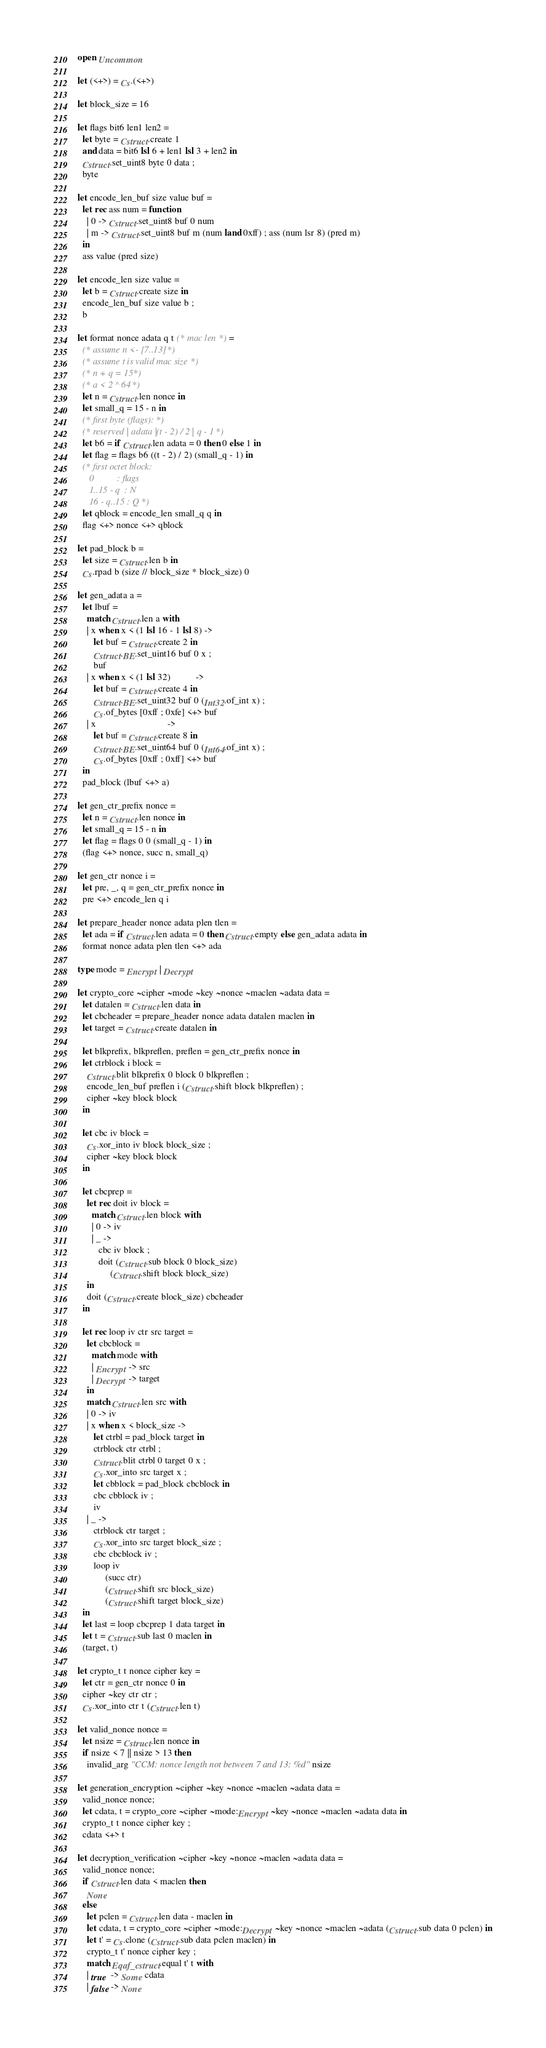<code> <loc_0><loc_0><loc_500><loc_500><_OCaml_>open Uncommon

let (<+>) = Cs.(<+>)

let block_size = 16

let flags bit6 len1 len2 =
  let byte = Cstruct.create 1
  and data = bit6 lsl 6 + len1 lsl 3 + len2 in
  Cstruct.set_uint8 byte 0 data ;
  byte

let encode_len_buf size value buf =
  let rec ass num = function
    | 0 -> Cstruct.set_uint8 buf 0 num
    | m -> Cstruct.set_uint8 buf m (num land 0xff) ; ass (num lsr 8) (pred m)
  in
  ass value (pred size)

let encode_len size value =
  let b = Cstruct.create size in
  encode_len_buf size value b ;
  b

let format nonce adata q t (* mac len *) =
  (* assume n <- [7..13] *)
  (* assume t is valid mac size *)
  (* n + q = 15 *)
  (* a < 2 ^ 64 *)
  let n = Cstruct.len nonce in
  let small_q = 15 - n in
  (* first byte (flags): *)
  (* reserved | adata | (t - 2) / 2 | q - 1 *)
  let b6 = if Cstruct.len adata = 0 then 0 else 1 in
  let flag = flags b6 ((t - 2) / 2) (small_q - 1) in
  (* first octet block:
     0          : flags
     1..15 - q  : N
     16 - q..15 : Q *)
  let qblock = encode_len small_q q in
  flag <+> nonce <+> qblock

let pad_block b =
  let size = Cstruct.len b in
  Cs.rpad b (size // block_size * block_size) 0

let gen_adata a =
  let lbuf =
    match Cstruct.len a with
    | x when x < (1 lsl 16 - 1 lsl 8) ->
       let buf = Cstruct.create 2 in
       Cstruct.BE.set_uint16 buf 0 x ;
       buf
    | x when x < (1 lsl 32)           ->
       let buf = Cstruct.create 4 in
       Cstruct.BE.set_uint32 buf 0 (Int32.of_int x) ;
       Cs.of_bytes [0xff ; 0xfe] <+> buf
    | x                               ->
       let buf = Cstruct.create 8 in
       Cstruct.BE.set_uint64 buf 0 (Int64.of_int x) ;
       Cs.of_bytes [0xff ; 0xff] <+> buf
  in
  pad_block (lbuf <+> a)

let gen_ctr_prefix nonce =
  let n = Cstruct.len nonce in
  let small_q = 15 - n in
  let flag = flags 0 0 (small_q - 1) in
  (flag <+> nonce, succ n, small_q)

let gen_ctr nonce i =
  let pre, _, q = gen_ctr_prefix nonce in
  pre <+> encode_len q i

let prepare_header nonce adata plen tlen =
  let ada = if Cstruct.len adata = 0 then Cstruct.empty else gen_adata adata in
  format nonce adata plen tlen <+> ada

type mode = Encrypt | Decrypt

let crypto_core ~cipher ~mode ~key ~nonce ~maclen ~adata data =
  let datalen = Cstruct.len data in
  let cbcheader = prepare_header nonce adata datalen maclen in
  let target = Cstruct.create datalen in

  let blkprefix, blkpreflen, preflen = gen_ctr_prefix nonce in
  let ctrblock i block =
    Cstruct.blit blkprefix 0 block 0 blkpreflen ;
    encode_len_buf preflen i (Cstruct.shift block blkpreflen) ;
    cipher ~key block block
  in

  let cbc iv block =
    Cs.xor_into iv block block_size ;
    cipher ~key block block
  in

  let cbcprep =
    let rec doit iv block =
      match Cstruct.len block with
      | 0 -> iv
      | _ ->
         cbc iv block ;
         doit (Cstruct.sub block 0 block_size)
              (Cstruct.shift block block_size)
    in
    doit (Cstruct.create block_size) cbcheader
  in

  let rec loop iv ctr src target =
    let cbcblock =
      match mode with
      | Encrypt -> src
      | Decrypt -> target
    in
    match Cstruct.len src with
    | 0 -> iv
    | x when x < block_size ->
       let ctrbl = pad_block target in
       ctrblock ctr ctrbl ;
       Cstruct.blit ctrbl 0 target 0 x ;
       Cs.xor_into src target x ;
       let cbblock = pad_block cbcblock in
       cbc cbblock iv ;
       iv
    | _ ->
       ctrblock ctr target ;
       Cs.xor_into src target block_size ;
       cbc cbcblock iv ;
       loop iv
            (succ ctr)
            (Cstruct.shift src block_size)
            (Cstruct.shift target block_size)
  in
  let last = loop cbcprep 1 data target in
  let t = Cstruct.sub last 0 maclen in
  (target, t)

let crypto_t t nonce cipher key =
  let ctr = gen_ctr nonce 0 in
  cipher ~key ctr ctr ;
  Cs.xor_into ctr t (Cstruct.len t)

let valid_nonce nonce =
  let nsize = Cstruct.len nonce in
  if nsize < 7 || nsize > 13 then
    invalid_arg "CCM: nonce length not between 7 and 13: %d" nsize

let generation_encryption ~cipher ~key ~nonce ~maclen ~adata data =
  valid_nonce nonce;
  let cdata, t = crypto_core ~cipher ~mode:Encrypt ~key ~nonce ~maclen ~adata data in
  crypto_t t nonce cipher key ;
  cdata <+> t

let decryption_verification ~cipher ~key ~nonce ~maclen ~adata data =
  valid_nonce nonce;
  if Cstruct.len data < maclen then
    None
  else
    let pclen = Cstruct.len data - maclen in
    let cdata, t = crypto_core ~cipher ~mode:Decrypt ~key ~nonce ~maclen ~adata (Cstruct.sub data 0 pclen) in
    let t' = Cs.clone (Cstruct.sub data pclen maclen) in
    crypto_t t' nonce cipher key ;
    match Eqaf_cstruct.equal t' t with
    | true  -> Some cdata
    | false -> None
</code> 